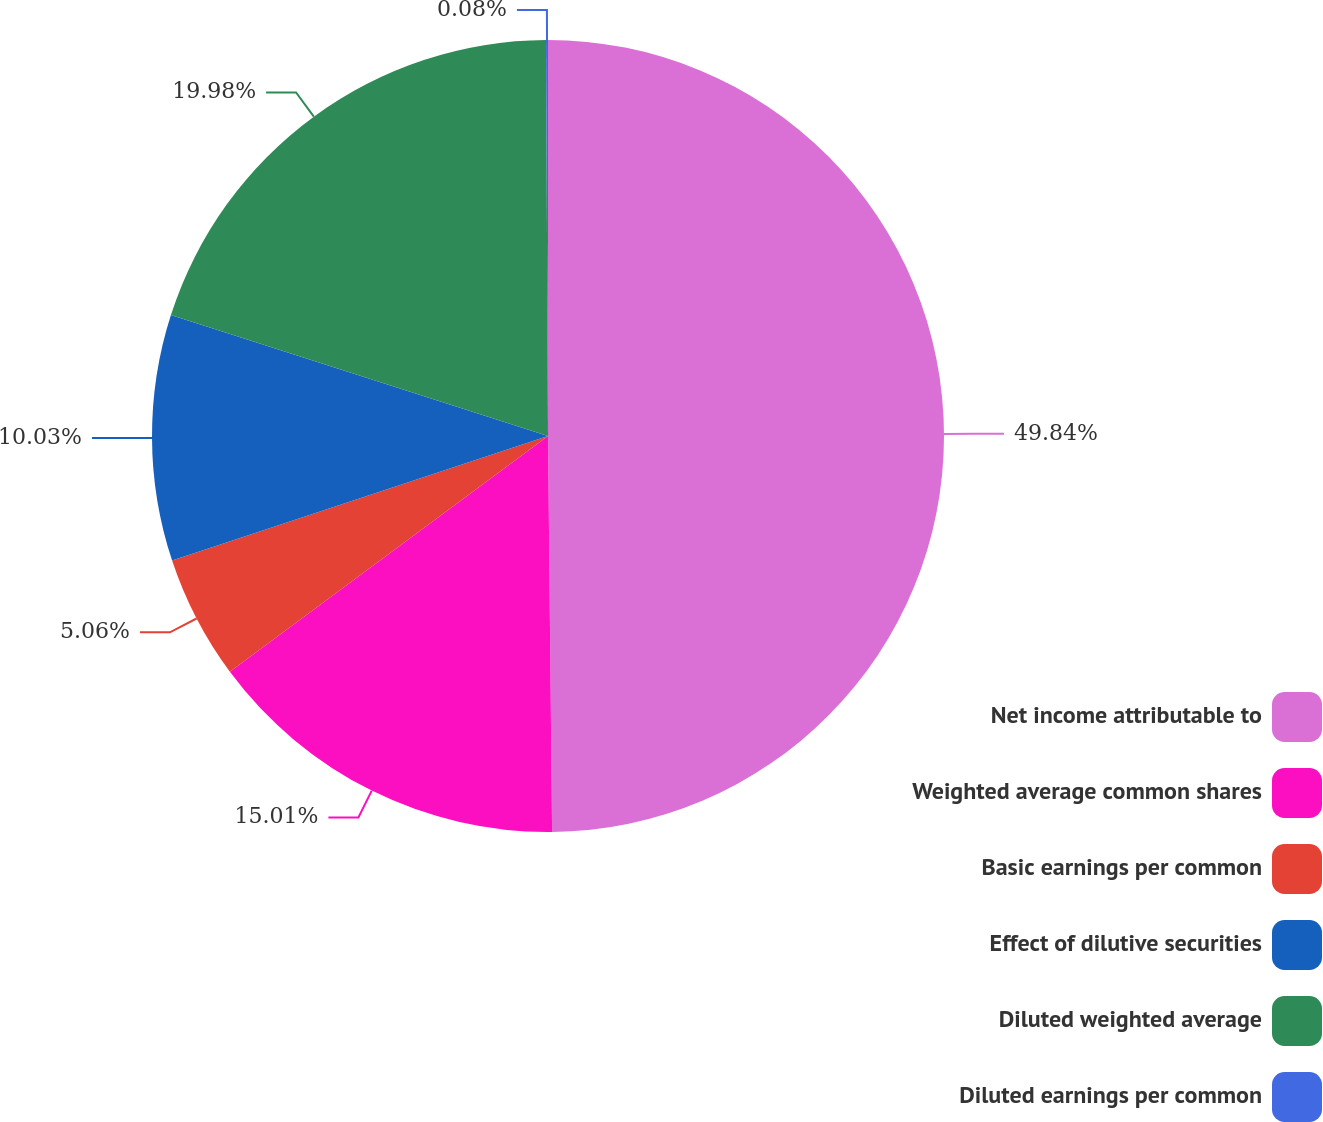Convert chart. <chart><loc_0><loc_0><loc_500><loc_500><pie_chart><fcel>Net income attributable to<fcel>Weighted average common shares<fcel>Basic earnings per common<fcel>Effect of dilutive securities<fcel>Diluted weighted average<fcel>Diluted earnings per common<nl><fcel>49.83%<fcel>15.01%<fcel>5.06%<fcel>10.03%<fcel>19.98%<fcel>0.08%<nl></chart> 